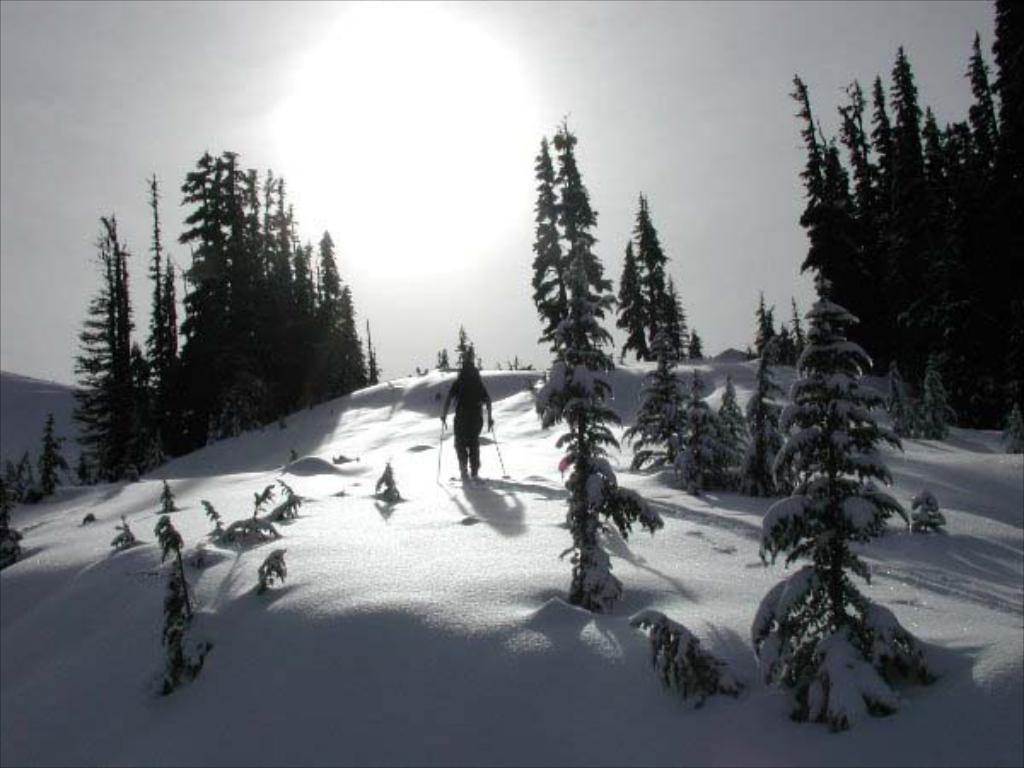How would you summarize this image in a sentence or two? In this image we can see a person is skating on land covered with ice. To the both sides of the image trees are present. The sky is covered with clouds. 